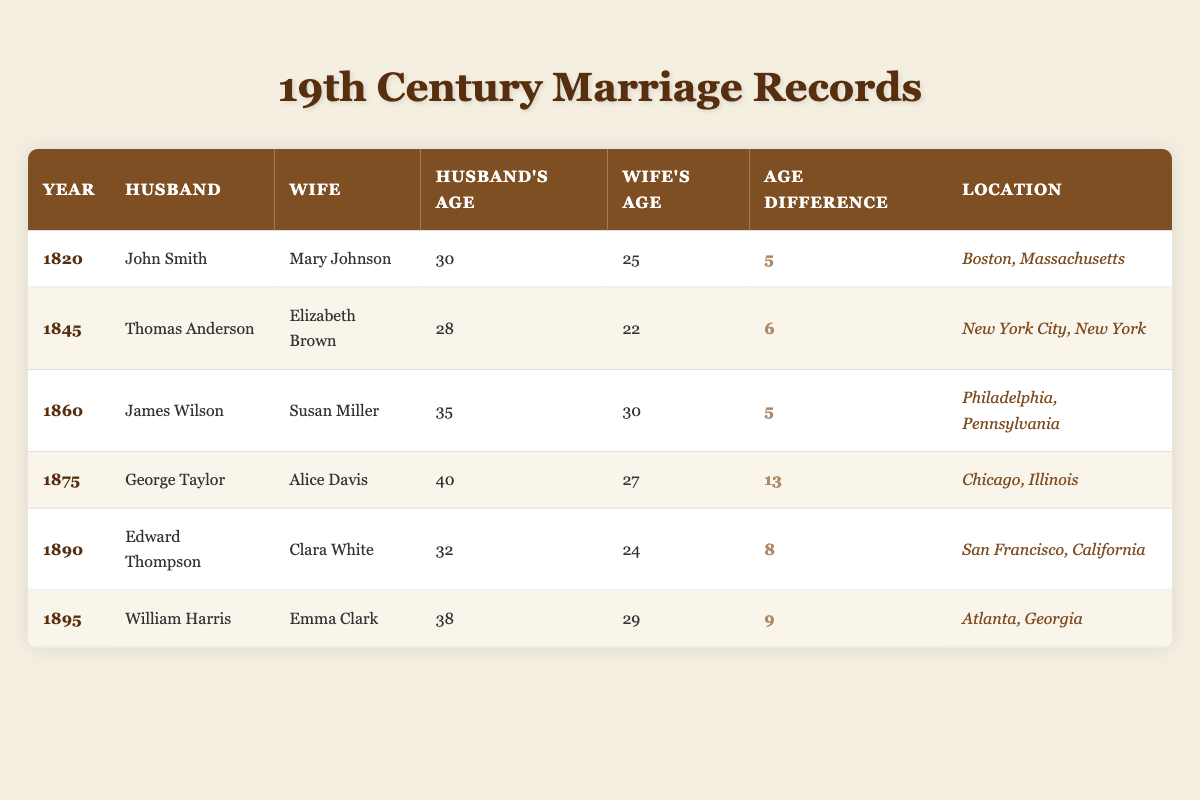What is the age difference between George Taylor and Alice Davis? In the row for the year 1875, George Taylor is listed as the husband at age 40 and Alice Davis as the wife at age 27. The age difference is calculated as 40 - 27 = 13.
Answer: 13 In what year did the couple with the largest age difference get married? By examining the "Age Difference" column, the largest age difference is recorded as 13 in the year 1875 for George Taylor and Alice Davis. Therefore, they were married in 1875.
Answer: 1875 Is it true that all husbands are older than their wives in this table? By evaluating the ages listed, all husbands' ages are higher than their wives' ages across the table, confirming that this statement is true.
Answer: Yes What was the average age of the husbands in this table? To find the average age of husbands, we sum their ages: (30 + 28 + 35 + 40 + 32 + 38) = 203. There are 6 husbands, so we divide 203 by 6 to get the average, which is approximately 33.83.
Answer: Approximately 33.83 Which marriage record has the youngest wife? The records show that Elizabeth Brown was 22 years old when married in 1845, and no other wife is younger than her age in this table. Thus, she is the youngest wife.
Answer: Elizabeth Brown How many couples have an age difference of 5 years? The table shows that there are two couples with an age difference of 5 years: John Smith and Mary Johnson (1820) and James Wilson and Susan Miller (1860). Therefore, the total number is two couples.
Answer: 2 What is the total age difference of all marriages recorded? Adding the age differences together (5 + 6 + 5 + 13 + 8 + 9) results in a total age difference of 46.
Answer: 46 Which location has a marriage with the youngest husband? The record for Thomas Anderson, who was the youngest husband at 28 years old, is from New York City in the year 1845.
Answer: New York City, New York 